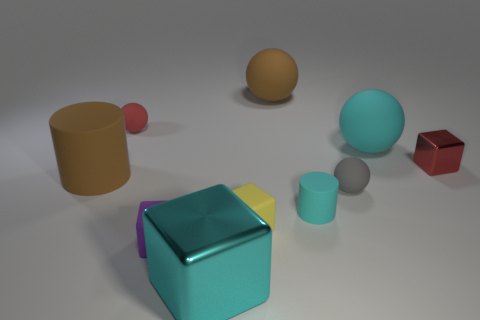Subtract all red cubes. How many cubes are left? 3 Subtract all purple cubes. How many cubes are left? 3 Add 2 cyan matte cylinders. How many cyan matte cylinders exist? 3 Subtract 1 cyan spheres. How many objects are left? 9 Subtract all balls. How many objects are left? 6 Subtract all cyan blocks. Subtract all green cylinders. How many blocks are left? 3 Subtract all tiny metallic objects. Subtract all small gray spheres. How many objects are left? 8 Add 8 cyan rubber balls. How many cyan rubber balls are left? 9 